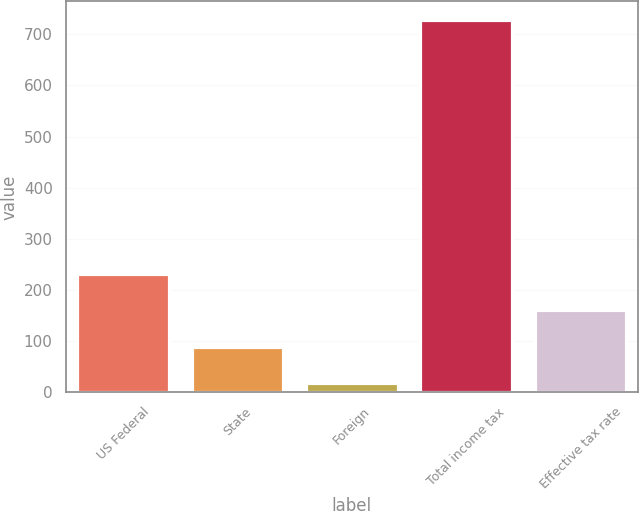Convert chart. <chart><loc_0><loc_0><loc_500><loc_500><bar_chart><fcel>US Federal<fcel>State<fcel>Foreign<fcel>Total income tax<fcel>Effective tax rate<nl><fcel>231<fcel>89<fcel>18<fcel>728<fcel>160<nl></chart> 